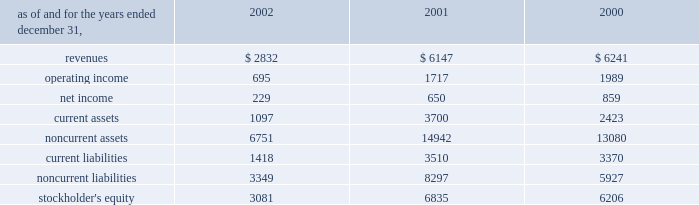Affiliated company .
The loss recorded on the sale was approximately $ 14 million and is recorded as a loss on sale of assets and asset impairment expenses in the accompanying consolidated statements of operations .
In the second quarter of 2002 , the company recorded an impairment charge of approximately $ 40 million , after income taxes , on an equity method investment in a telecommunications company in latin america held by edc .
The impairment charge resulted from sustained poor operating performance coupled with recent funding problems at the invested company .
During 2001 , the company lost operational control of central electricity supply corporation ( 2018 2018cesco 2019 2019 ) , a distribution company located in the state of orissa , india .
Cesco is accounted for as a cost method investment .
In may 2000 , the company completed the acquisition of 100% ( 100 % ) of tractebel power ltd ( 2018 2018tpl 2019 2019 ) for approximately $ 67 million and assumed liabilities of approximately $ 200 million .
Tpl owned 46% ( 46 % ) of nigen .
The company also acquired an additional 6% ( 6 % ) interest in nigen from minority stockholders during the year ended december 31 , 2000 through the issuance of approximately 99000 common shares of aes stock valued at approximately $ 4.9 million .
With the completion of these transactions , the company owns approximately 98% ( 98 % ) of nigen 2019s common stock and began consolidating its financial results beginning may 12 , 2000 .
Approximately $ 100 million of the purchase price was allocated to excess of costs over net assets acquired and was amortized through january 1 , 2002 at which time the company adopted sfas no .
142 and ceased amortization of goodwill .
In august 2000 , a subsidiary of the company acquired a 49% ( 49 % ) interest in songas limited ( 2018 2018songas 2019 2019 ) for approximately $ 40 million .
The company acquired an additional 16.79% ( 16.79 % ) of songas for approximately $ 12.5 million , and the company began consolidating this entity in 2002 .
Songas owns the songo songo gas-to-electricity project in tanzania .
In december 2002 , the company signed a sales purchase agreement to sell songas .
The sale is expected to close in early 2003 .
See note 4 for further discussion of the transaction .
The table presents summarized comparative financial information ( in millions ) for the company 2019s investments in 50% ( 50 % ) or less owned investments accounted for using the equity method. .
In 2002 , 2001 and 2000 , the results of operations and the financial position of cemig were negatively impacted by the devaluation of the brazilian real and the impairment charge recorded in 2002 .
The brazilian real devalued 32% ( 32 % ) , 19% ( 19 % ) and 8% ( 8 % ) for the years ended december 31 , 2002 , 2001 and 2000 , respectively .
The company recorded $ 83 million , $ 210 million , and $ 64 million of pre-tax non-cash foreign currency transaction losses on its investments in brazilian equity method affiliates during 2002 , 2001 and 2000 , respectively. .
What was the percentage change in revenues for investments in 50% ( 50 % ) or less owned investments accounted for using the equity method between 2001 and 2002? 
Computations: ((2832 - 6147) / 6147)
Answer: -0.53929. Affiliated company .
The loss recorded on the sale was approximately $ 14 million and is recorded as a loss on sale of assets and asset impairment expenses in the accompanying consolidated statements of operations .
In the second quarter of 2002 , the company recorded an impairment charge of approximately $ 40 million , after income taxes , on an equity method investment in a telecommunications company in latin america held by edc .
The impairment charge resulted from sustained poor operating performance coupled with recent funding problems at the invested company .
During 2001 , the company lost operational control of central electricity supply corporation ( 2018 2018cesco 2019 2019 ) , a distribution company located in the state of orissa , india .
Cesco is accounted for as a cost method investment .
In may 2000 , the company completed the acquisition of 100% ( 100 % ) of tractebel power ltd ( 2018 2018tpl 2019 2019 ) for approximately $ 67 million and assumed liabilities of approximately $ 200 million .
Tpl owned 46% ( 46 % ) of nigen .
The company also acquired an additional 6% ( 6 % ) interest in nigen from minority stockholders during the year ended december 31 , 2000 through the issuance of approximately 99000 common shares of aes stock valued at approximately $ 4.9 million .
With the completion of these transactions , the company owns approximately 98% ( 98 % ) of nigen 2019s common stock and began consolidating its financial results beginning may 12 , 2000 .
Approximately $ 100 million of the purchase price was allocated to excess of costs over net assets acquired and was amortized through january 1 , 2002 at which time the company adopted sfas no .
142 and ceased amortization of goodwill .
In august 2000 , a subsidiary of the company acquired a 49% ( 49 % ) interest in songas limited ( 2018 2018songas 2019 2019 ) for approximately $ 40 million .
The company acquired an additional 16.79% ( 16.79 % ) of songas for approximately $ 12.5 million , and the company began consolidating this entity in 2002 .
Songas owns the songo songo gas-to-electricity project in tanzania .
In december 2002 , the company signed a sales purchase agreement to sell songas .
The sale is expected to close in early 2003 .
See note 4 for further discussion of the transaction .
The table presents summarized comparative financial information ( in millions ) for the company 2019s investments in 50% ( 50 % ) or less owned investments accounted for using the equity method. .
In 2002 , 2001 and 2000 , the results of operations and the financial position of cemig were negatively impacted by the devaluation of the brazilian real and the impairment charge recorded in 2002 .
The brazilian real devalued 32% ( 32 % ) , 19% ( 19 % ) and 8% ( 8 % ) for the years ended december 31 , 2002 , 2001 and 2000 , respectively .
The company recorded $ 83 million , $ 210 million , and $ 64 million of pre-tax non-cash foreign currency transaction losses on its investments in brazilian equity method affiliates during 2002 , 2001 and 2000 , respectively. .
What was 2002 return on stockholder's equity for the less than 50% ( 50 % ) owned investments , based on net income? 
Computations: (229 / 3081)
Answer: 0.07433. 